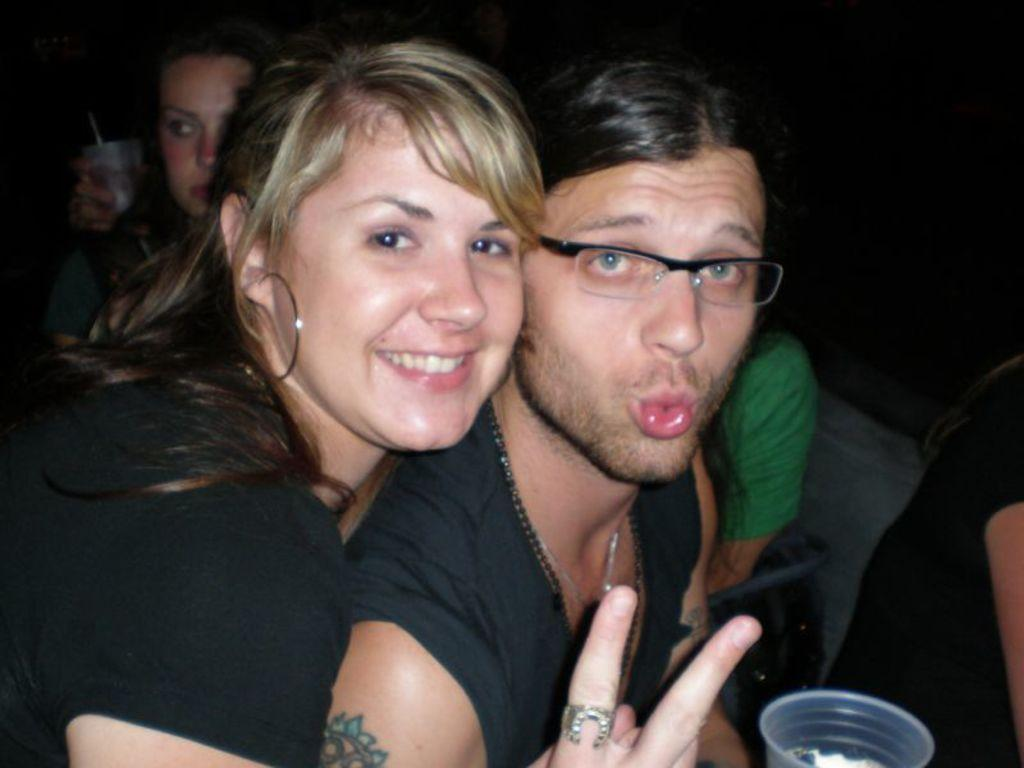How many people are in the image? There are people in the image, but the exact number is not specified. Can you describe any specific features of one of the people? Yes, one person is wearing glasses. What object is located at the bottom of the image? There is a glass at the bottom of the image. What is the color of the background in the image? The background of the image is dark. What flavor of ghost can be seen in the image? There is no ghost present in the image, so it is not possible to determine its flavor. 